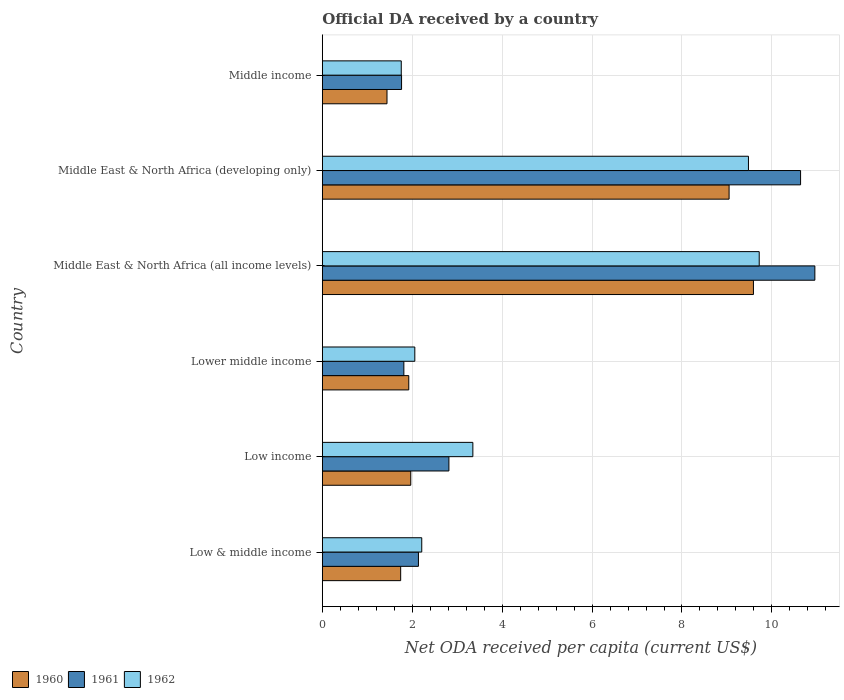Are the number of bars per tick equal to the number of legend labels?
Your answer should be compact. Yes. How many bars are there on the 2nd tick from the bottom?
Make the answer very short. 3. What is the label of the 3rd group of bars from the top?
Keep it short and to the point. Middle East & North Africa (all income levels). In how many cases, is the number of bars for a given country not equal to the number of legend labels?
Make the answer very short. 0. What is the ODA received in in 1961 in Low & middle income?
Ensure brevity in your answer.  2.14. Across all countries, what is the maximum ODA received in in 1960?
Offer a very short reply. 9.59. Across all countries, what is the minimum ODA received in in 1960?
Your response must be concise. 1.44. In which country was the ODA received in in 1960 maximum?
Offer a very short reply. Middle East & North Africa (all income levels). What is the total ODA received in in 1961 in the graph?
Your answer should be very brief. 30.12. What is the difference between the ODA received in in 1961 in Low & middle income and that in Middle income?
Ensure brevity in your answer.  0.38. What is the difference between the ODA received in in 1960 in Middle income and the ODA received in in 1962 in Middle East & North Africa (all income levels)?
Your response must be concise. -8.28. What is the average ODA received in in 1960 per country?
Provide a succinct answer. 4.28. What is the difference between the ODA received in in 1962 and ODA received in in 1960 in Middle income?
Provide a short and direct response. 0.32. In how many countries, is the ODA received in in 1960 greater than 10 US$?
Offer a terse response. 0. What is the ratio of the ODA received in in 1961 in Lower middle income to that in Middle income?
Offer a terse response. 1.03. Is the ODA received in in 1962 in Middle East & North Africa (all income levels) less than that in Middle income?
Provide a short and direct response. No. Is the difference between the ODA received in in 1962 in Lower middle income and Middle East & North Africa (developing only) greater than the difference between the ODA received in in 1960 in Lower middle income and Middle East & North Africa (developing only)?
Offer a terse response. No. What is the difference between the highest and the second highest ODA received in in 1962?
Offer a terse response. 0.24. What is the difference between the highest and the lowest ODA received in in 1961?
Ensure brevity in your answer.  9.19. Is the sum of the ODA received in in 1960 in Lower middle income and Middle East & North Africa (all income levels) greater than the maximum ODA received in in 1961 across all countries?
Your answer should be compact. Yes. What does the 2nd bar from the top in Middle East & North Africa (all income levels) represents?
Your response must be concise. 1961. What does the 1st bar from the bottom in Low income represents?
Your answer should be very brief. 1960. Are all the bars in the graph horizontal?
Your answer should be compact. Yes. What is the difference between two consecutive major ticks on the X-axis?
Keep it short and to the point. 2. Does the graph contain grids?
Your answer should be compact. Yes. How many legend labels are there?
Offer a very short reply. 3. How are the legend labels stacked?
Give a very brief answer. Horizontal. What is the title of the graph?
Provide a short and direct response. Official DA received by a country. What is the label or title of the X-axis?
Your response must be concise. Net ODA received per capita (current US$). What is the Net ODA received per capita (current US$) of 1960 in Low & middle income?
Ensure brevity in your answer.  1.74. What is the Net ODA received per capita (current US$) of 1961 in Low & middle income?
Keep it short and to the point. 2.14. What is the Net ODA received per capita (current US$) of 1962 in Low & middle income?
Provide a succinct answer. 2.21. What is the Net ODA received per capita (current US$) of 1960 in Low income?
Give a very brief answer. 1.97. What is the Net ODA received per capita (current US$) of 1961 in Low income?
Provide a short and direct response. 2.82. What is the Net ODA received per capita (current US$) in 1962 in Low income?
Make the answer very short. 3.35. What is the Net ODA received per capita (current US$) of 1960 in Lower middle income?
Provide a short and direct response. 1.92. What is the Net ODA received per capita (current US$) in 1961 in Lower middle income?
Provide a succinct answer. 1.81. What is the Net ODA received per capita (current US$) in 1962 in Lower middle income?
Your response must be concise. 2.06. What is the Net ODA received per capita (current US$) in 1960 in Middle East & North Africa (all income levels)?
Your response must be concise. 9.59. What is the Net ODA received per capita (current US$) of 1961 in Middle East & North Africa (all income levels)?
Make the answer very short. 10.96. What is the Net ODA received per capita (current US$) of 1962 in Middle East & North Africa (all income levels)?
Your answer should be compact. 9.72. What is the Net ODA received per capita (current US$) of 1960 in Middle East & North Africa (developing only)?
Offer a very short reply. 9.05. What is the Net ODA received per capita (current US$) in 1961 in Middle East & North Africa (developing only)?
Your answer should be compact. 10.64. What is the Net ODA received per capita (current US$) in 1962 in Middle East & North Africa (developing only)?
Provide a short and direct response. 9.48. What is the Net ODA received per capita (current US$) in 1960 in Middle income?
Your answer should be very brief. 1.44. What is the Net ODA received per capita (current US$) in 1961 in Middle income?
Offer a terse response. 1.76. What is the Net ODA received per capita (current US$) in 1962 in Middle income?
Your answer should be compact. 1.76. Across all countries, what is the maximum Net ODA received per capita (current US$) in 1960?
Provide a short and direct response. 9.59. Across all countries, what is the maximum Net ODA received per capita (current US$) of 1961?
Make the answer very short. 10.96. Across all countries, what is the maximum Net ODA received per capita (current US$) of 1962?
Offer a very short reply. 9.72. Across all countries, what is the minimum Net ODA received per capita (current US$) in 1960?
Keep it short and to the point. 1.44. Across all countries, what is the minimum Net ODA received per capita (current US$) in 1961?
Offer a terse response. 1.76. Across all countries, what is the minimum Net ODA received per capita (current US$) in 1962?
Your answer should be compact. 1.76. What is the total Net ODA received per capita (current US$) in 1960 in the graph?
Make the answer very short. 25.71. What is the total Net ODA received per capita (current US$) in 1961 in the graph?
Give a very brief answer. 30.12. What is the total Net ODA received per capita (current US$) in 1962 in the graph?
Ensure brevity in your answer.  28.57. What is the difference between the Net ODA received per capita (current US$) of 1960 in Low & middle income and that in Low income?
Ensure brevity in your answer.  -0.22. What is the difference between the Net ODA received per capita (current US$) in 1961 in Low & middle income and that in Low income?
Make the answer very short. -0.68. What is the difference between the Net ODA received per capita (current US$) in 1962 in Low & middle income and that in Low income?
Offer a terse response. -1.14. What is the difference between the Net ODA received per capita (current US$) in 1960 in Low & middle income and that in Lower middle income?
Make the answer very short. -0.18. What is the difference between the Net ODA received per capita (current US$) in 1961 in Low & middle income and that in Lower middle income?
Provide a short and direct response. 0.32. What is the difference between the Net ODA received per capita (current US$) in 1962 in Low & middle income and that in Lower middle income?
Your response must be concise. 0.15. What is the difference between the Net ODA received per capita (current US$) of 1960 in Low & middle income and that in Middle East & North Africa (all income levels)?
Make the answer very short. -7.85. What is the difference between the Net ODA received per capita (current US$) of 1961 in Low & middle income and that in Middle East & North Africa (all income levels)?
Provide a short and direct response. -8.82. What is the difference between the Net ODA received per capita (current US$) in 1962 in Low & middle income and that in Middle East & North Africa (all income levels)?
Keep it short and to the point. -7.51. What is the difference between the Net ODA received per capita (current US$) of 1960 in Low & middle income and that in Middle East & North Africa (developing only)?
Ensure brevity in your answer.  -7.31. What is the difference between the Net ODA received per capita (current US$) in 1961 in Low & middle income and that in Middle East & North Africa (developing only)?
Your answer should be very brief. -8.5. What is the difference between the Net ODA received per capita (current US$) in 1962 in Low & middle income and that in Middle East & North Africa (developing only)?
Offer a very short reply. -7.27. What is the difference between the Net ODA received per capita (current US$) in 1960 in Low & middle income and that in Middle income?
Ensure brevity in your answer.  0.3. What is the difference between the Net ODA received per capita (current US$) in 1961 in Low & middle income and that in Middle income?
Provide a succinct answer. 0.38. What is the difference between the Net ODA received per capita (current US$) in 1962 in Low & middle income and that in Middle income?
Your answer should be compact. 0.46. What is the difference between the Net ODA received per capita (current US$) of 1960 in Low income and that in Lower middle income?
Offer a very short reply. 0.04. What is the difference between the Net ODA received per capita (current US$) in 1961 in Low income and that in Lower middle income?
Provide a succinct answer. 1. What is the difference between the Net ODA received per capita (current US$) in 1962 in Low income and that in Lower middle income?
Provide a short and direct response. 1.29. What is the difference between the Net ODA received per capita (current US$) of 1960 in Low income and that in Middle East & North Africa (all income levels)?
Provide a succinct answer. -7.62. What is the difference between the Net ODA received per capita (current US$) in 1961 in Low income and that in Middle East & North Africa (all income levels)?
Offer a very short reply. -8.14. What is the difference between the Net ODA received per capita (current US$) in 1962 in Low income and that in Middle East & North Africa (all income levels)?
Make the answer very short. -6.37. What is the difference between the Net ODA received per capita (current US$) in 1960 in Low income and that in Middle East & North Africa (developing only)?
Give a very brief answer. -7.08. What is the difference between the Net ODA received per capita (current US$) in 1961 in Low income and that in Middle East & North Africa (developing only)?
Keep it short and to the point. -7.82. What is the difference between the Net ODA received per capita (current US$) in 1962 in Low income and that in Middle East & North Africa (developing only)?
Give a very brief answer. -6.13. What is the difference between the Net ODA received per capita (current US$) in 1960 in Low income and that in Middle income?
Your answer should be compact. 0.53. What is the difference between the Net ODA received per capita (current US$) in 1961 in Low income and that in Middle income?
Your answer should be compact. 1.05. What is the difference between the Net ODA received per capita (current US$) in 1962 in Low income and that in Middle income?
Offer a very short reply. 1.59. What is the difference between the Net ODA received per capita (current US$) in 1960 in Lower middle income and that in Middle East & North Africa (all income levels)?
Give a very brief answer. -7.67. What is the difference between the Net ODA received per capita (current US$) of 1961 in Lower middle income and that in Middle East & North Africa (all income levels)?
Offer a very short reply. -9.14. What is the difference between the Net ODA received per capita (current US$) of 1962 in Lower middle income and that in Middle East & North Africa (all income levels)?
Offer a terse response. -7.66. What is the difference between the Net ODA received per capita (current US$) of 1960 in Lower middle income and that in Middle East & North Africa (developing only)?
Ensure brevity in your answer.  -7.13. What is the difference between the Net ODA received per capita (current US$) in 1961 in Lower middle income and that in Middle East & North Africa (developing only)?
Your answer should be compact. -8.82. What is the difference between the Net ODA received per capita (current US$) of 1962 in Lower middle income and that in Middle East & North Africa (developing only)?
Give a very brief answer. -7.42. What is the difference between the Net ODA received per capita (current US$) of 1960 in Lower middle income and that in Middle income?
Offer a very short reply. 0.48. What is the difference between the Net ODA received per capita (current US$) in 1961 in Lower middle income and that in Middle income?
Offer a very short reply. 0.05. What is the difference between the Net ODA received per capita (current US$) of 1962 in Lower middle income and that in Middle income?
Keep it short and to the point. 0.3. What is the difference between the Net ODA received per capita (current US$) in 1960 in Middle East & North Africa (all income levels) and that in Middle East & North Africa (developing only)?
Offer a very short reply. 0.54. What is the difference between the Net ODA received per capita (current US$) in 1961 in Middle East & North Africa (all income levels) and that in Middle East & North Africa (developing only)?
Provide a succinct answer. 0.32. What is the difference between the Net ODA received per capita (current US$) of 1962 in Middle East & North Africa (all income levels) and that in Middle East & North Africa (developing only)?
Make the answer very short. 0.24. What is the difference between the Net ODA received per capita (current US$) of 1960 in Middle East & North Africa (all income levels) and that in Middle income?
Offer a very short reply. 8.15. What is the difference between the Net ODA received per capita (current US$) in 1961 in Middle East & North Africa (all income levels) and that in Middle income?
Offer a very short reply. 9.19. What is the difference between the Net ODA received per capita (current US$) of 1962 in Middle East & North Africa (all income levels) and that in Middle income?
Your response must be concise. 7.96. What is the difference between the Net ODA received per capita (current US$) of 1960 in Middle East & North Africa (developing only) and that in Middle income?
Ensure brevity in your answer.  7.61. What is the difference between the Net ODA received per capita (current US$) in 1961 in Middle East & North Africa (developing only) and that in Middle income?
Offer a terse response. 8.88. What is the difference between the Net ODA received per capita (current US$) of 1962 in Middle East & North Africa (developing only) and that in Middle income?
Provide a short and direct response. 7.72. What is the difference between the Net ODA received per capita (current US$) in 1960 in Low & middle income and the Net ODA received per capita (current US$) in 1961 in Low income?
Keep it short and to the point. -1.07. What is the difference between the Net ODA received per capita (current US$) in 1960 in Low & middle income and the Net ODA received per capita (current US$) in 1962 in Low income?
Offer a terse response. -1.61. What is the difference between the Net ODA received per capita (current US$) of 1961 in Low & middle income and the Net ODA received per capita (current US$) of 1962 in Low income?
Your answer should be very brief. -1.21. What is the difference between the Net ODA received per capita (current US$) in 1960 in Low & middle income and the Net ODA received per capita (current US$) in 1961 in Lower middle income?
Ensure brevity in your answer.  -0.07. What is the difference between the Net ODA received per capita (current US$) in 1960 in Low & middle income and the Net ODA received per capita (current US$) in 1962 in Lower middle income?
Your answer should be very brief. -0.31. What is the difference between the Net ODA received per capita (current US$) in 1961 in Low & middle income and the Net ODA received per capita (current US$) in 1962 in Lower middle income?
Provide a short and direct response. 0.08. What is the difference between the Net ODA received per capita (current US$) of 1960 in Low & middle income and the Net ODA received per capita (current US$) of 1961 in Middle East & North Africa (all income levels)?
Your answer should be very brief. -9.21. What is the difference between the Net ODA received per capita (current US$) in 1960 in Low & middle income and the Net ODA received per capita (current US$) in 1962 in Middle East & North Africa (all income levels)?
Keep it short and to the point. -7.98. What is the difference between the Net ODA received per capita (current US$) of 1961 in Low & middle income and the Net ODA received per capita (current US$) of 1962 in Middle East & North Africa (all income levels)?
Give a very brief answer. -7.58. What is the difference between the Net ODA received per capita (current US$) in 1960 in Low & middle income and the Net ODA received per capita (current US$) in 1961 in Middle East & North Africa (developing only)?
Make the answer very short. -8.9. What is the difference between the Net ODA received per capita (current US$) of 1960 in Low & middle income and the Net ODA received per capita (current US$) of 1962 in Middle East & North Africa (developing only)?
Ensure brevity in your answer.  -7.74. What is the difference between the Net ODA received per capita (current US$) of 1961 in Low & middle income and the Net ODA received per capita (current US$) of 1962 in Middle East & North Africa (developing only)?
Keep it short and to the point. -7.34. What is the difference between the Net ODA received per capita (current US$) in 1960 in Low & middle income and the Net ODA received per capita (current US$) in 1961 in Middle income?
Your response must be concise. -0.02. What is the difference between the Net ODA received per capita (current US$) in 1960 in Low & middle income and the Net ODA received per capita (current US$) in 1962 in Middle income?
Provide a short and direct response. -0.01. What is the difference between the Net ODA received per capita (current US$) in 1961 in Low & middle income and the Net ODA received per capita (current US$) in 1962 in Middle income?
Make the answer very short. 0.38. What is the difference between the Net ODA received per capita (current US$) in 1960 in Low income and the Net ODA received per capita (current US$) in 1961 in Lower middle income?
Your answer should be very brief. 0.15. What is the difference between the Net ODA received per capita (current US$) in 1960 in Low income and the Net ODA received per capita (current US$) in 1962 in Lower middle income?
Your answer should be very brief. -0.09. What is the difference between the Net ODA received per capita (current US$) of 1961 in Low income and the Net ODA received per capita (current US$) of 1962 in Lower middle income?
Give a very brief answer. 0.76. What is the difference between the Net ODA received per capita (current US$) in 1960 in Low income and the Net ODA received per capita (current US$) in 1961 in Middle East & North Africa (all income levels)?
Offer a terse response. -8.99. What is the difference between the Net ODA received per capita (current US$) of 1960 in Low income and the Net ODA received per capita (current US$) of 1962 in Middle East & North Africa (all income levels)?
Your answer should be compact. -7.75. What is the difference between the Net ODA received per capita (current US$) of 1961 in Low income and the Net ODA received per capita (current US$) of 1962 in Middle East & North Africa (all income levels)?
Your answer should be very brief. -6.9. What is the difference between the Net ODA received per capita (current US$) in 1960 in Low income and the Net ODA received per capita (current US$) in 1961 in Middle East & North Africa (developing only)?
Keep it short and to the point. -8.67. What is the difference between the Net ODA received per capita (current US$) of 1960 in Low income and the Net ODA received per capita (current US$) of 1962 in Middle East & North Africa (developing only)?
Keep it short and to the point. -7.51. What is the difference between the Net ODA received per capita (current US$) in 1961 in Low income and the Net ODA received per capita (current US$) in 1962 in Middle East & North Africa (developing only)?
Ensure brevity in your answer.  -6.66. What is the difference between the Net ODA received per capita (current US$) in 1960 in Low income and the Net ODA received per capita (current US$) in 1961 in Middle income?
Provide a short and direct response. 0.2. What is the difference between the Net ODA received per capita (current US$) of 1960 in Low income and the Net ODA received per capita (current US$) of 1962 in Middle income?
Your answer should be compact. 0.21. What is the difference between the Net ODA received per capita (current US$) of 1961 in Low income and the Net ODA received per capita (current US$) of 1962 in Middle income?
Ensure brevity in your answer.  1.06. What is the difference between the Net ODA received per capita (current US$) in 1960 in Lower middle income and the Net ODA received per capita (current US$) in 1961 in Middle East & North Africa (all income levels)?
Give a very brief answer. -9.03. What is the difference between the Net ODA received per capita (current US$) in 1960 in Lower middle income and the Net ODA received per capita (current US$) in 1962 in Middle East & North Africa (all income levels)?
Provide a short and direct response. -7.8. What is the difference between the Net ODA received per capita (current US$) of 1961 in Lower middle income and the Net ODA received per capita (current US$) of 1962 in Middle East & North Africa (all income levels)?
Keep it short and to the point. -7.9. What is the difference between the Net ODA received per capita (current US$) of 1960 in Lower middle income and the Net ODA received per capita (current US$) of 1961 in Middle East & North Africa (developing only)?
Your answer should be very brief. -8.72. What is the difference between the Net ODA received per capita (current US$) in 1960 in Lower middle income and the Net ODA received per capita (current US$) in 1962 in Middle East & North Africa (developing only)?
Ensure brevity in your answer.  -7.56. What is the difference between the Net ODA received per capita (current US$) of 1961 in Lower middle income and the Net ODA received per capita (current US$) of 1962 in Middle East & North Africa (developing only)?
Make the answer very short. -7.67. What is the difference between the Net ODA received per capita (current US$) of 1960 in Lower middle income and the Net ODA received per capita (current US$) of 1961 in Middle income?
Provide a succinct answer. 0.16. What is the difference between the Net ODA received per capita (current US$) of 1960 in Lower middle income and the Net ODA received per capita (current US$) of 1962 in Middle income?
Keep it short and to the point. 0.17. What is the difference between the Net ODA received per capita (current US$) of 1961 in Lower middle income and the Net ODA received per capita (current US$) of 1962 in Middle income?
Offer a terse response. 0.06. What is the difference between the Net ODA received per capita (current US$) in 1960 in Middle East & North Africa (all income levels) and the Net ODA received per capita (current US$) in 1961 in Middle East & North Africa (developing only)?
Give a very brief answer. -1.05. What is the difference between the Net ODA received per capita (current US$) of 1960 in Middle East & North Africa (all income levels) and the Net ODA received per capita (current US$) of 1962 in Middle East & North Africa (developing only)?
Provide a succinct answer. 0.11. What is the difference between the Net ODA received per capita (current US$) in 1961 in Middle East & North Africa (all income levels) and the Net ODA received per capita (current US$) in 1962 in Middle East & North Africa (developing only)?
Provide a short and direct response. 1.48. What is the difference between the Net ODA received per capita (current US$) of 1960 in Middle East & North Africa (all income levels) and the Net ODA received per capita (current US$) of 1961 in Middle income?
Your response must be concise. 7.83. What is the difference between the Net ODA received per capita (current US$) of 1960 in Middle East & North Africa (all income levels) and the Net ODA received per capita (current US$) of 1962 in Middle income?
Your answer should be compact. 7.83. What is the difference between the Net ODA received per capita (current US$) in 1961 in Middle East & North Africa (all income levels) and the Net ODA received per capita (current US$) in 1962 in Middle income?
Provide a succinct answer. 9.2. What is the difference between the Net ODA received per capita (current US$) in 1960 in Middle East & North Africa (developing only) and the Net ODA received per capita (current US$) in 1961 in Middle income?
Offer a terse response. 7.29. What is the difference between the Net ODA received per capita (current US$) of 1960 in Middle East & North Africa (developing only) and the Net ODA received per capita (current US$) of 1962 in Middle income?
Offer a very short reply. 7.29. What is the difference between the Net ODA received per capita (current US$) of 1961 in Middle East & North Africa (developing only) and the Net ODA received per capita (current US$) of 1962 in Middle income?
Give a very brief answer. 8.88. What is the average Net ODA received per capita (current US$) in 1960 per country?
Provide a succinct answer. 4.28. What is the average Net ODA received per capita (current US$) in 1961 per country?
Your response must be concise. 5.02. What is the average Net ODA received per capita (current US$) of 1962 per country?
Keep it short and to the point. 4.76. What is the difference between the Net ODA received per capita (current US$) in 1960 and Net ODA received per capita (current US$) in 1961 in Low & middle income?
Give a very brief answer. -0.4. What is the difference between the Net ODA received per capita (current US$) of 1960 and Net ODA received per capita (current US$) of 1962 in Low & middle income?
Give a very brief answer. -0.47. What is the difference between the Net ODA received per capita (current US$) of 1961 and Net ODA received per capita (current US$) of 1962 in Low & middle income?
Provide a short and direct response. -0.07. What is the difference between the Net ODA received per capita (current US$) in 1960 and Net ODA received per capita (current US$) in 1961 in Low income?
Provide a succinct answer. -0.85. What is the difference between the Net ODA received per capita (current US$) of 1960 and Net ODA received per capita (current US$) of 1962 in Low income?
Make the answer very short. -1.38. What is the difference between the Net ODA received per capita (current US$) in 1961 and Net ODA received per capita (current US$) in 1962 in Low income?
Your answer should be compact. -0.53. What is the difference between the Net ODA received per capita (current US$) of 1960 and Net ODA received per capita (current US$) of 1961 in Lower middle income?
Your answer should be compact. 0.11. What is the difference between the Net ODA received per capita (current US$) of 1960 and Net ODA received per capita (current US$) of 1962 in Lower middle income?
Your answer should be very brief. -0.13. What is the difference between the Net ODA received per capita (current US$) of 1961 and Net ODA received per capita (current US$) of 1962 in Lower middle income?
Your answer should be compact. -0.24. What is the difference between the Net ODA received per capita (current US$) in 1960 and Net ODA received per capita (current US$) in 1961 in Middle East & North Africa (all income levels)?
Provide a short and direct response. -1.37. What is the difference between the Net ODA received per capita (current US$) in 1960 and Net ODA received per capita (current US$) in 1962 in Middle East & North Africa (all income levels)?
Provide a short and direct response. -0.13. What is the difference between the Net ODA received per capita (current US$) of 1961 and Net ODA received per capita (current US$) of 1962 in Middle East & North Africa (all income levels)?
Make the answer very short. 1.24. What is the difference between the Net ODA received per capita (current US$) in 1960 and Net ODA received per capita (current US$) in 1961 in Middle East & North Africa (developing only)?
Your answer should be very brief. -1.59. What is the difference between the Net ODA received per capita (current US$) of 1960 and Net ODA received per capita (current US$) of 1962 in Middle East & North Africa (developing only)?
Your answer should be compact. -0.43. What is the difference between the Net ODA received per capita (current US$) of 1961 and Net ODA received per capita (current US$) of 1962 in Middle East & North Africa (developing only)?
Ensure brevity in your answer.  1.16. What is the difference between the Net ODA received per capita (current US$) in 1960 and Net ODA received per capita (current US$) in 1961 in Middle income?
Provide a short and direct response. -0.32. What is the difference between the Net ODA received per capita (current US$) in 1960 and Net ODA received per capita (current US$) in 1962 in Middle income?
Provide a succinct answer. -0.32. What is the difference between the Net ODA received per capita (current US$) of 1961 and Net ODA received per capita (current US$) of 1962 in Middle income?
Give a very brief answer. 0.01. What is the ratio of the Net ODA received per capita (current US$) of 1960 in Low & middle income to that in Low income?
Offer a very short reply. 0.89. What is the ratio of the Net ODA received per capita (current US$) of 1961 in Low & middle income to that in Low income?
Give a very brief answer. 0.76. What is the ratio of the Net ODA received per capita (current US$) in 1962 in Low & middle income to that in Low income?
Ensure brevity in your answer.  0.66. What is the ratio of the Net ODA received per capita (current US$) of 1960 in Low & middle income to that in Lower middle income?
Ensure brevity in your answer.  0.91. What is the ratio of the Net ODA received per capita (current US$) of 1961 in Low & middle income to that in Lower middle income?
Offer a very short reply. 1.18. What is the ratio of the Net ODA received per capita (current US$) of 1962 in Low & middle income to that in Lower middle income?
Give a very brief answer. 1.08. What is the ratio of the Net ODA received per capita (current US$) of 1960 in Low & middle income to that in Middle East & North Africa (all income levels)?
Your answer should be very brief. 0.18. What is the ratio of the Net ODA received per capita (current US$) of 1961 in Low & middle income to that in Middle East & North Africa (all income levels)?
Your answer should be compact. 0.2. What is the ratio of the Net ODA received per capita (current US$) in 1962 in Low & middle income to that in Middle East & North Africa (all income levels)?
Make the answer very short. 0.23. What is the ratio of the Net ODA received per capita (current US$) of 1960 in Low & middle income to that in Middle East & North Africa (developing only)?
Give a very brief answer. 0.19. What is the ratio of the Net ODA received per capita (current US$) in 1961 in Low & middle income to that in Middle East & North Africa (developing only)?
Provide a succinct answer. 0.2. What is the ratio of the Net ODA received per capita (current US$) of 1962 in Low & middle income to that in Middle East & North Africa (developing only)?
Ensure brevity in your answer.  0.23. What is the ratio of the Net ODA received per capita (current US$) in 1960 in Low & middle income to that in Middle income?
Give a very brief answer. 1.21. What is the ratio of the Net ODA received per capita (current US$) in 1961 in Low & middle income to that in Middle income?
Keep it short and to the point. 1.21. What is the ratio of the Net ODA received per capita (current US$) of 1962 in Low & middle income to that in Middle income?
Ensure brevity in your answer.  1.26. What is the ratio of the Net ODA received per capita (current US$) in 1960 in Low income to that in Lower middle income?
Make the answer very short. 1.02. What is the ratio of the Net ODA received per capita (current US$) of 1961 in Low income to that in Lower middle income?
Your response must be concise. 1.55. What is the ratio of the Net ODA received per capita (current US$) in 1962 in Low income to that in Lower middle income?
Provide a short and direct response. 1.63. What is the ratio of the Net ODA received per capita (current US$) in 1960 in Low income to that in Middle East & North Africa (all income levels)?
Offer a very short reply. 0.21. What is the ratio of the Net ODA received per capita (current US$) in 1961 in Low income to that in Middle East & North Africa (all income levels)?
Offer a terse response. 0.26. What is the ratio of the Net ODA received per capita (current US$) in 1962 in Low income to that in Middle East & North Africa (all income levels)?
Provide a succinct answer. 0.34. What is the ratio of the Net ODA received per capita (current US$) in 1960 in Low income to that in Middle East & North Africa (developing only)?
Your answer should be very brief. 0.22. What is the ratio of the Net ODA received per capita (current US$) in 1961 in Low income to that in Middle East & North Africa (developing only)?
Your answer should be very brief. 0.26. What is the ratio of the Net ODA received per capita (current US$) in 1962 in Low income to that in Middle East & North Africa (developing only)?
Give a very brief answer. 0.35. What is the ratio of the Net ODA received per capita (current US$) in 1960 in Low income to that in Middle income?
Provide a succinct answer. 1.37. What is the ratio of the Net ODA received per capita (current US$) in 1961 in Low income to that in Middle income?
Ensure brevity in your answer.  1.6. What is the ratio of the Net ODA received per capita (current US$) in 1962 in Low income to that in Middle income?
Offer a terse response. 1.91. What is the ratio of the Net ODA received per capita (current US$) in 1960 in Lower middle income to that in Middle East & North Africa (all income levels)?
Ensure brevity in your answer.  0.2. What is the ratio of the Net ODA received per capita (current US$) of 1961 in Lower middle income to that in Middle East & North Africa (all income levels)?
Make the answer very short. 0.17. What is the ratio of the Net ODA received per capita (current US$) in 1962 in Lower middle income to that in Middle East & North Africa (all income levels)?
Provide a succinct answer. 0.21. What is the ratio of the Net ODA received per capita (current US$) in 1960 in Lower middle income to that in Middle East & North Africa (developing only)?
Offer a terse response. 0.21. What is the ratio of the Net ODA received per capita (current US$) of 1961 in Lower middle income to that in Middle East & North Africa (developing only)?
Offer a very short reply. 0.17. What is the ratio of the Net ODA received per capita (current US$) in 1962 in Lower middle income to that in Middle East & North Africa (developing only)?
Offer a very short reply. 0.22. What is the ratio of the Net ODA received per capita (current US$) of 1960 in Lower middle income to that in Middle income?
Ensure brevity in your answer.  1.34. What is the ratio of the Net ODA received per capita (current US$) of 1961 in Lower middle income to that in Middle income?
Give a very brief answer. 1.03. What is the ratio of the Net ODA received per capita (current US$) of 1962 in Lower middle income to that in Middle income?
Your answer should be very brief. 1.17. What is the ratio of the Net ODA received per capita (current US$) in 1960 in Middle East & North Africa (all income levels) to that in Middle East & North Africa (developing only)?
Make the answer very short. 1.06. What is the ratio of the Net ODA received per capita (current US$) in 1961 in Middle East & North Africa (all income levels) to that in Middle East & North Africa (developing only)?
Offer a very short reply. 1.03. What is the ratio of the Net ODA received per capita (current US$) of 1962 in Middle East & North Africa (all income levels) to that in Middle East & North Africa (developing only)?
Provide a short and direct response. 1.03. What is the ratio of the Net ODA received per capita (current US$) of 1960 in Middle East & North Africa (all income levels) to that in Middle income?
Provide a succinct answer. 6.67. What is the ratio of the Net ODA received per capita (current US$) in 1961 in Middle East & North Africa (all income levels) to that in Middle income?
Offer a very short reply. 6.22. What is the ratio of the Net ODA received per capita (current US$) of 1962 in Middle East & North Africa (all income levels) to that in Middle income?
Keep it short and to the point. 5.53. What is the ratio of the Net ODA received per capita (current US$) of 1960 in Middle East & North Africa (developing only) to that in Middle income?
Your answer should be compact. 6.29. What is the ratio of the Net ODA received per capita (current US$) of 1961 in Middle East & North Africa (developing only) to that in Middle income?
Give a very brief answer. 6.04. What is the ratio of the Net ODA received per capita (current US$) in 1962 in Middle East & North Africa (developing only) to that in Middle income?
Offer a very short reply. 5.4. What is the difference between the highest and the second highest Net ODA received per capita (current US$) in 1960?
Keep it short and to the point. 0.54. What is the difference between the highest and the second highest Net ODA received per capita (current US$) in 1961?
Provide a short and direct response. 0.32. What is the difference between the highest and the second highest Net ODA received per capita (current US$) of 1962?
Ensure brevity in your answer.  0.24. What is the difference between the highest and the lowest Net ODA received per capita (current US$) of 1960?
Keep it short and to the point. 8.15. What is the difference between the highest and the lowest Net ODA received per capita (current US$) of 1961?
Your answer should be compact. 9.19. What is the difference between the highest and the lowest Net ODA received per capita (current US$) in 1962?
Your answer should be compact. 7.96. 